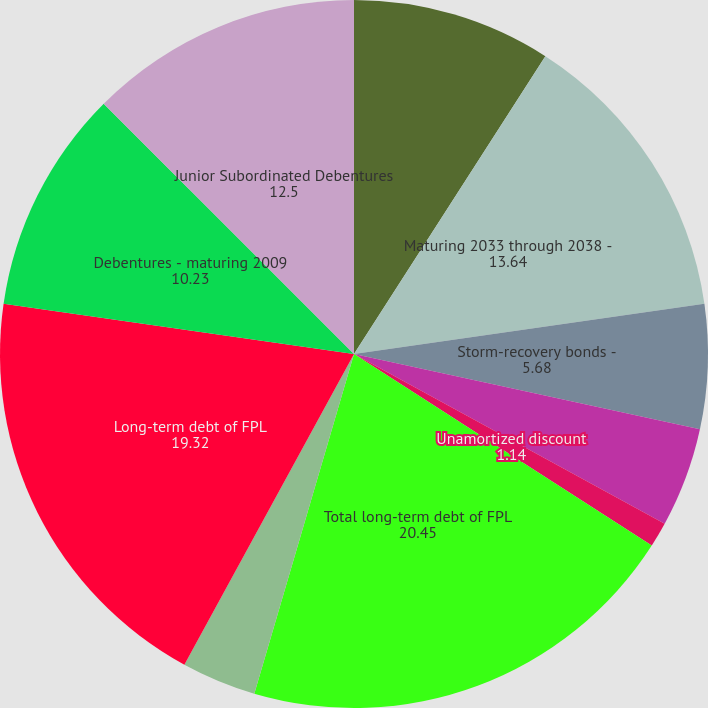Convert chart to OTSL. <chart><loc_0><loc_0><loc_500><loc_500><pie_chart><fcel>Maturing 2009 through 2017 -<fcel>Maturing 2033 through 2038 -<fcel>Storm-recovery bonds -<fcel>Pollution control solid waste<fcel>Unamortized discount<fcel>Total long-term debt of FPL<fcel>Less current maturities of<fcel>Long-term debt of FPL<fcel>Debentures - maturing 2009<fcel>Junior Subordinated Debentures<nl><fcel>9.09%<fcel>13.64%<fcel>5.68%<fcel>4.55%<fcel>1.14%<fcel>20.45%<fcel>3.41%<fcel>19.32%<fcel>10.23%<fcel>12.5%<nl></chart> 